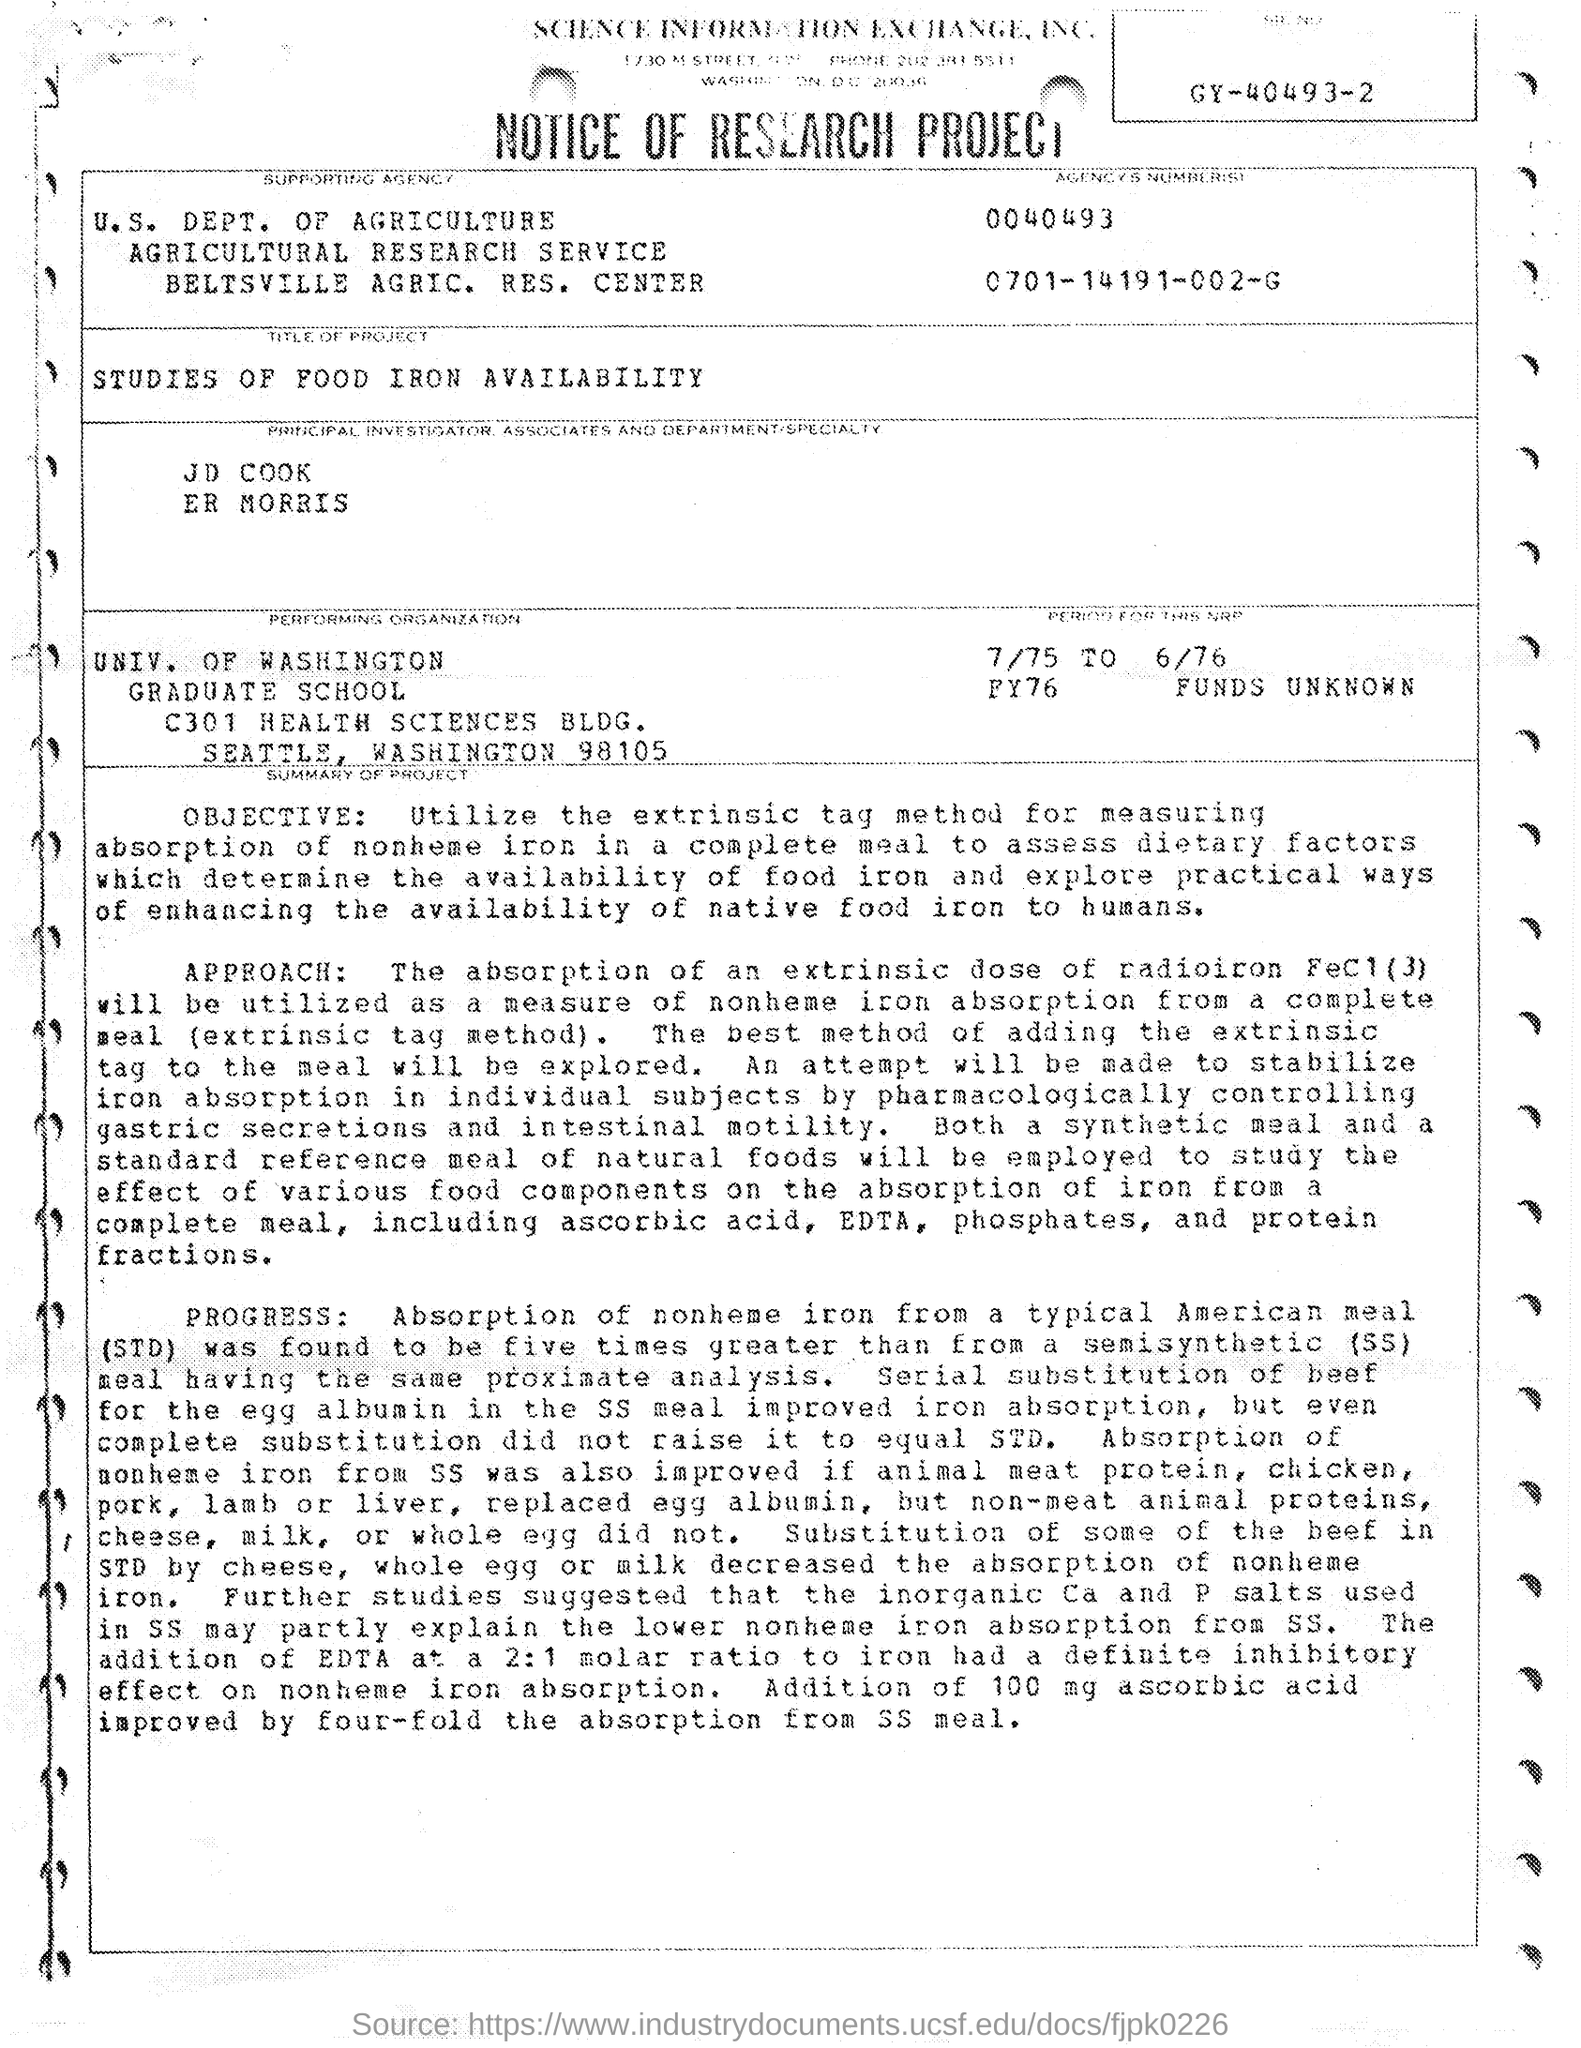What is the title of the project?
Your answer should be very brief. Studies of Food Iron Availability. What is the name of the performing organization?
Provide a short and direct response. UNIV. OF WASHINGTON. 